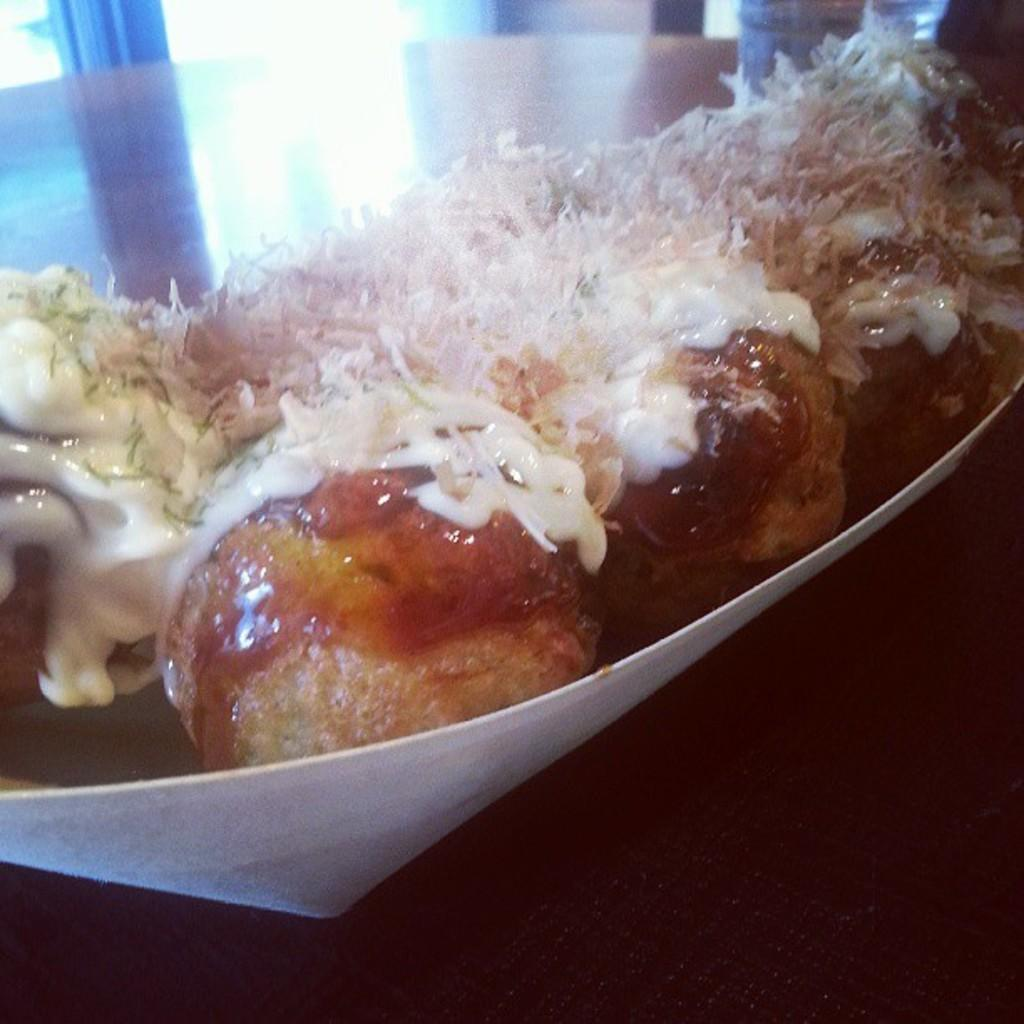Where was the image taken? The image is taken indoors. What piece of furniture is present in the image? There is a table in the image. What is placed on the table? There is a plate on the table. What is on the plate? There is a food item on the plate. What is the name of the food item on the plate? The provided facts do not mention the name of the food item on the plate. --- Facts: 1. There is a person in the image. 2. The person is wearing a hat. 3. The person is holding a book. 4. There is a chair in the image. 5. The chair is next to a table. Absurd Topics: rain, dance, ocean Conversation: Who is in the image? There is a person in the image. What is the person wearing? The person is wearing a hat. What is the person holding? The person is holding a book. What piece of furniture is in the image? There is a chair in the image. Where is the chair located in relation to the table? The chair is next to a table. Reasoning: Let's think step by step in order to produce the conversation. We start by identifying the main subject in the image, which is the person. Then, we describe the person's attire and what they are holding. Next, we mention the furniture in the image, which is a chair. Finally, we describe the location of the chair in relation to the table. Each question is designed to elicit a specific detail about the image that is known from the provided facts. Absurd Question/Answer: Can you see the ocean in the image? There is no mention of an ocean in the provided facts, and therefore, it cannot be seen in the image. 